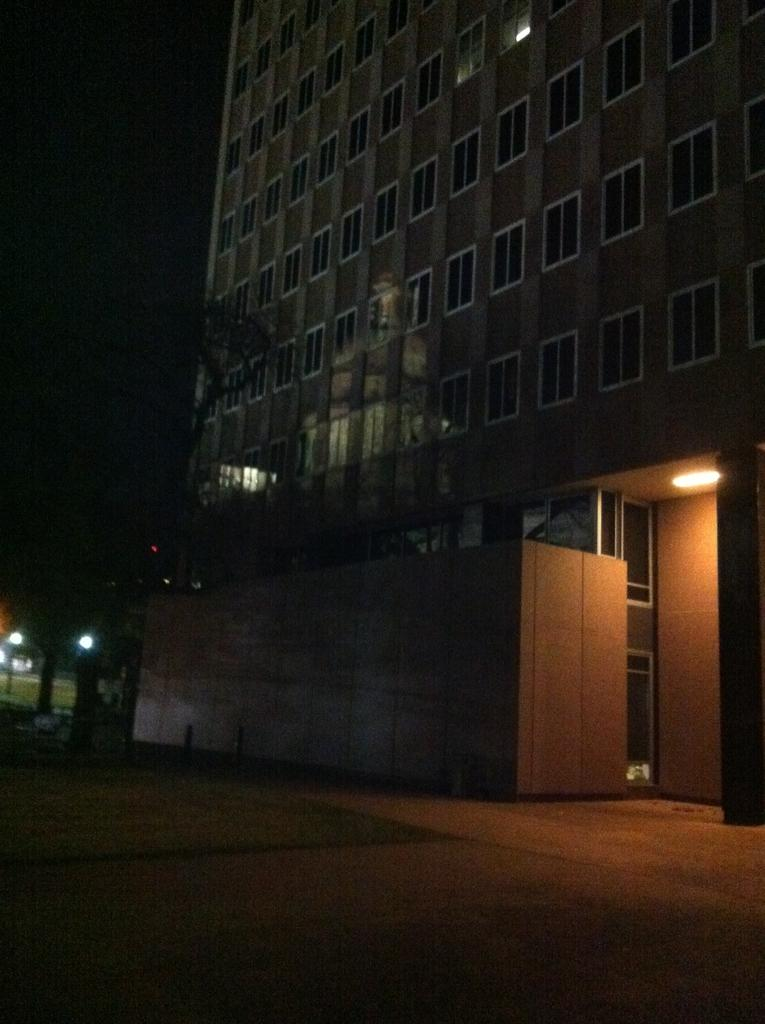What type of natural elements can be seen in the image? There are trees in the image. What type of artificial elements can be seen in the image? There are street lights in the image. What type of terrain is depicted in the image? The image depicts land. What is located on the left side of the image? There is a vehicle on the left side of the image. What structure is visible in the background of the image? There is a building in the background of the image. What feature is present on the building in the image? The building has a light attached to its roof. What type of art can be seen on the coast in the image? There is no art or coast present in the image; it depicts land with trees, street lights, a vehicle, and a building. How does the beginner navigate the image? The term "beginner" does not apply to the image, as it is a static representation and does not require navigation. 